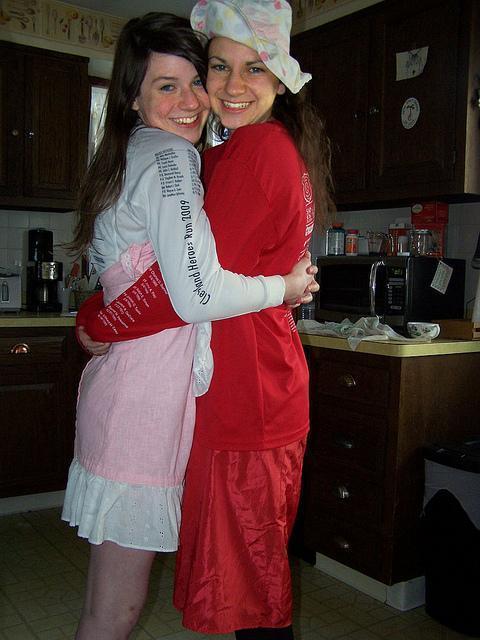How many people are in the photo?
Give a very brief answer. 2. How many people are in the picture?
Give a very brief answer. 2. How many cars face the bus?
Give a very brief answer. 0. 